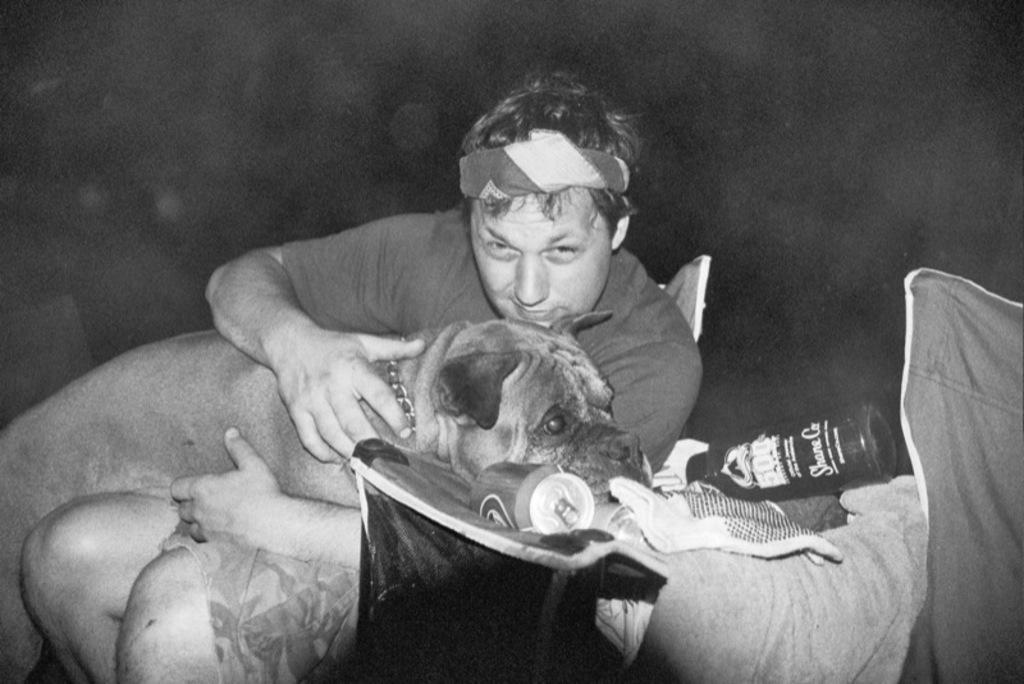Can you describe this image briefly? In the given image we can see a person, dog, can and a bottle. 